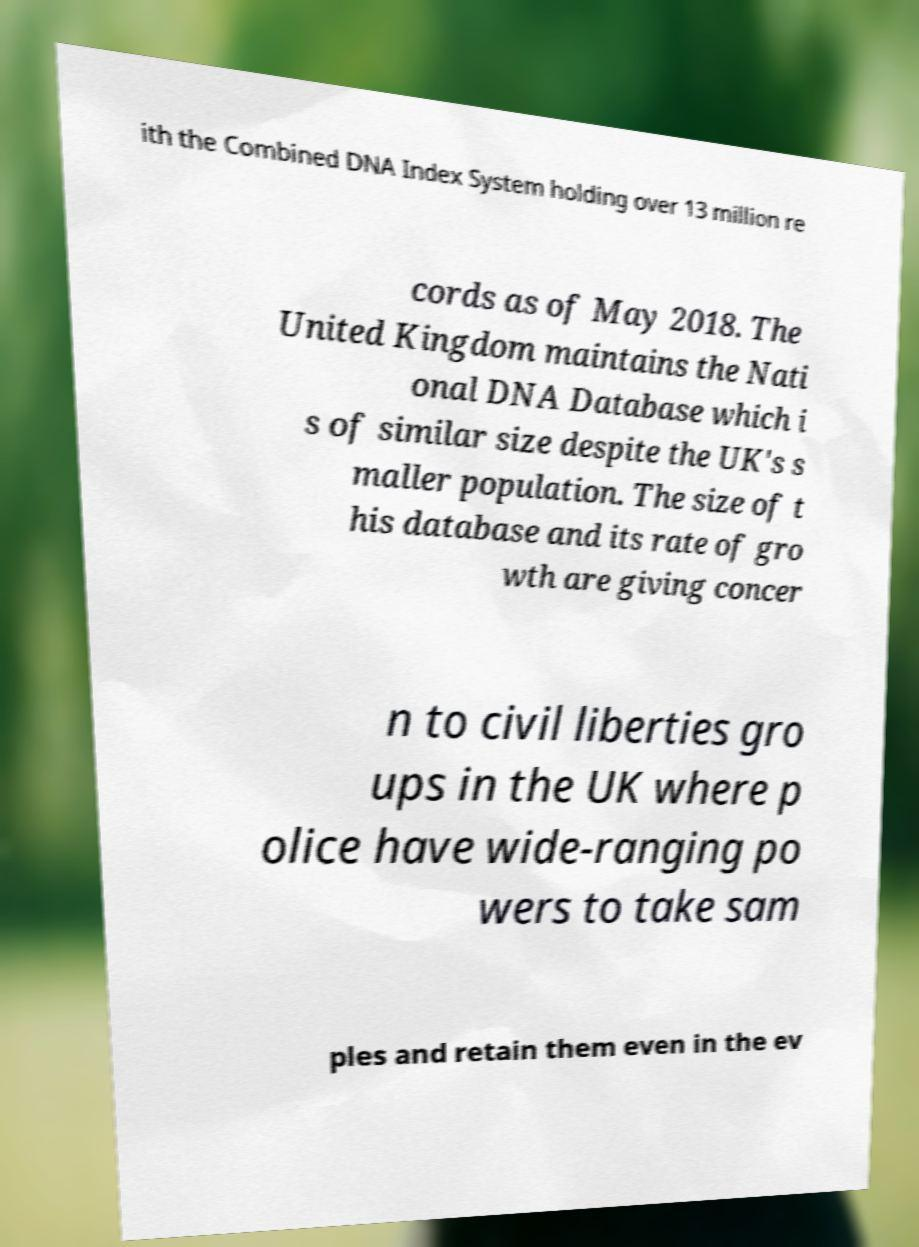I need the written content from this picture converted into text. Can you do that? ith the Combined DNA Index System holding over 13 million re cords as of May 2018. The United Kingdom maintains the Nati onal DNA Database which i s of similar size despite the UK's s maller population. The size of t his database and its rate of gro wth are giving concer n to civil liberties gro ups in the UK where p olice have wide-ranging po wers to take sam ples and retain them even in the ev 